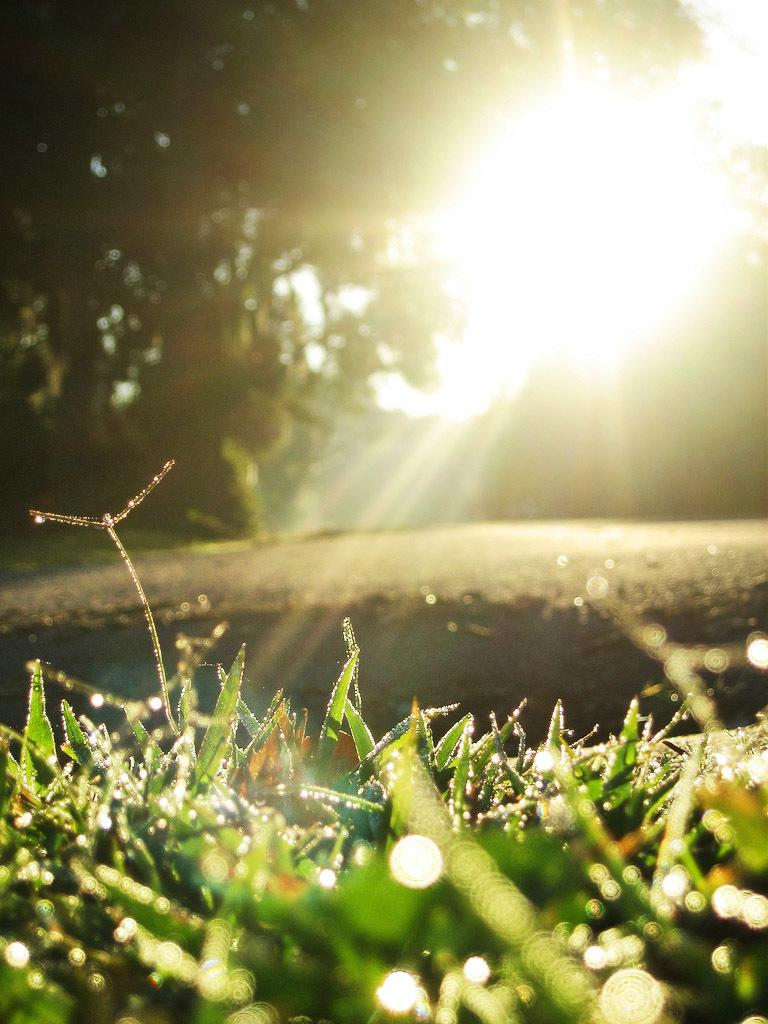What type of surface can be seen at the bottom of the image? There is grass at the bottom of the image. What natural elements are present in the image? The ground, trees, and sunlight are present in the image. Can you describe the lighting conditions in the image? Sunlight is present in the image, indicating that it is daytime. Are there any beds visible in the image? No, there are no beds present in the image. Can you see any fire or sparks in the image? No, there is no fire or spark visible in the image. 